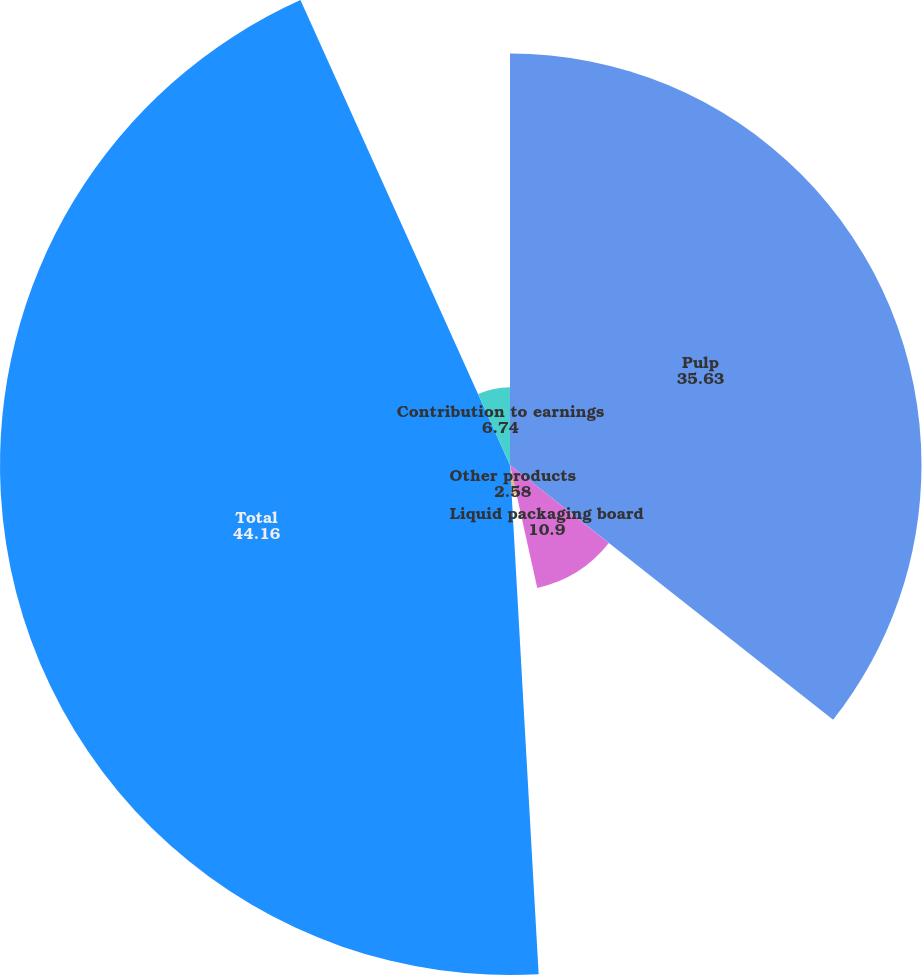Convert chart. <chart><loc_0><loc_0><loc_500><loc_500><pie_chart><fcel>Pulp<fcel>Liquid packaging board<fcel>Other products<fcel>Total<fcel>Contribution to earnings<nl><fcel>35.63%<fcel>10.9%<fcel>2.58%<fcel>44.16%<fcel>6.74%<nl></chart> 